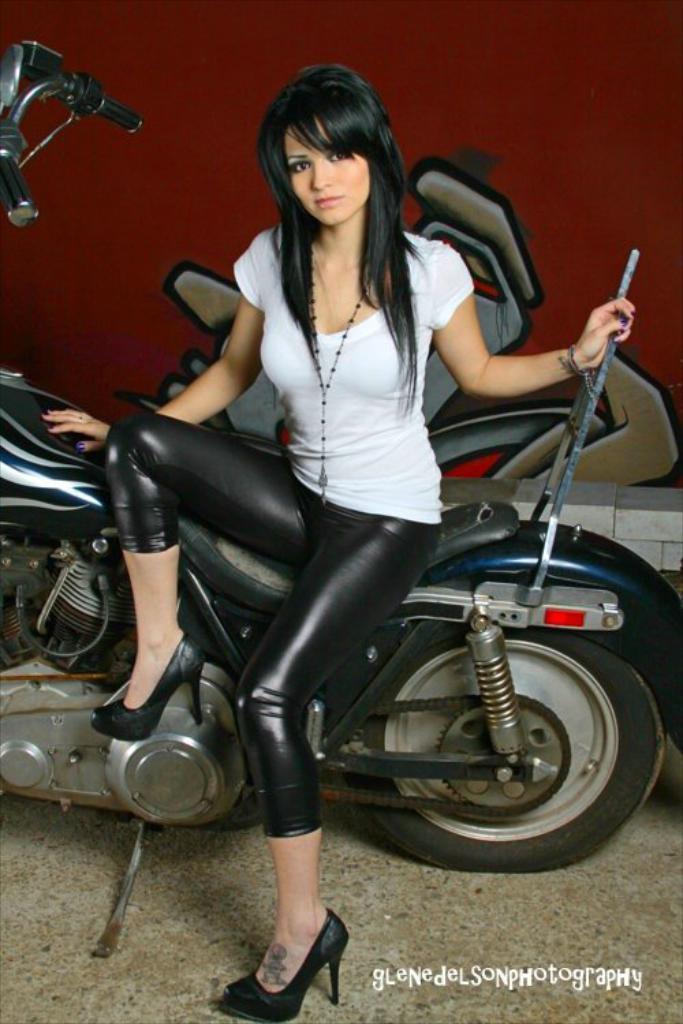In one or two sentences, can you explain what this image depicts? This image has a woman is sitting on the bike and holding a rod of it is wearing a white shirt and black pant and heels to her leg. 